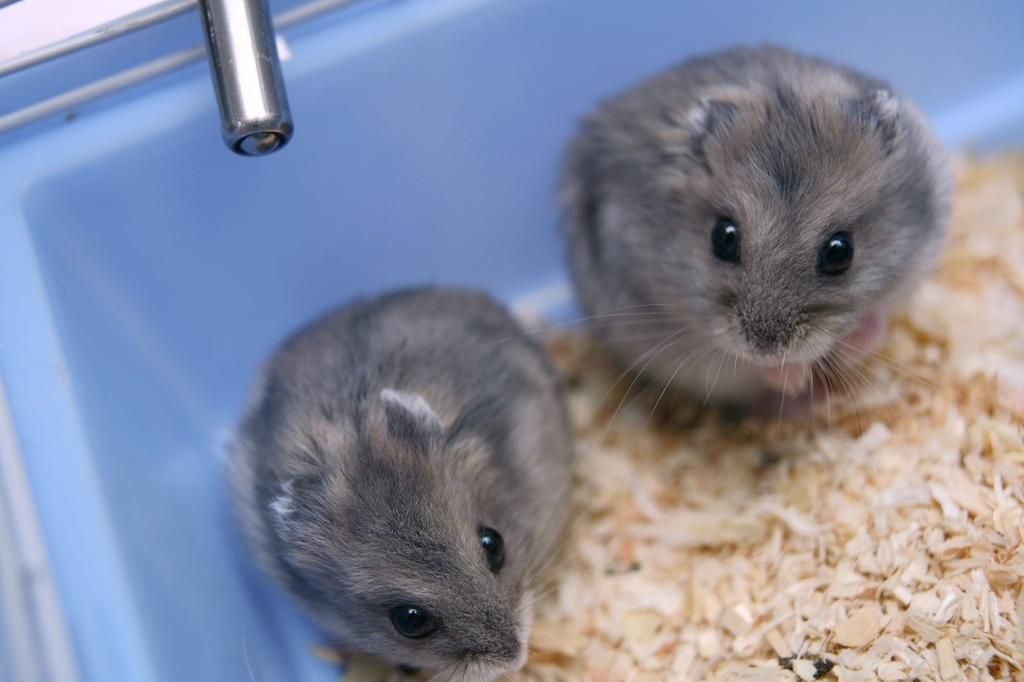How many mice are present in the image? There are two mice in the image. Where are the mice located? The mice are in a tub. What type of object can be seen in the image that is made of metal? There is a metal object in the image. What can be found in the image that might be used for fuel or construction? It appears there is chopped wood in the image. What type of berry is being used to promote peace in the image? There is no berry or reference to peace in the image; it features two mice in a tub, a metal object, and chopped wood. 